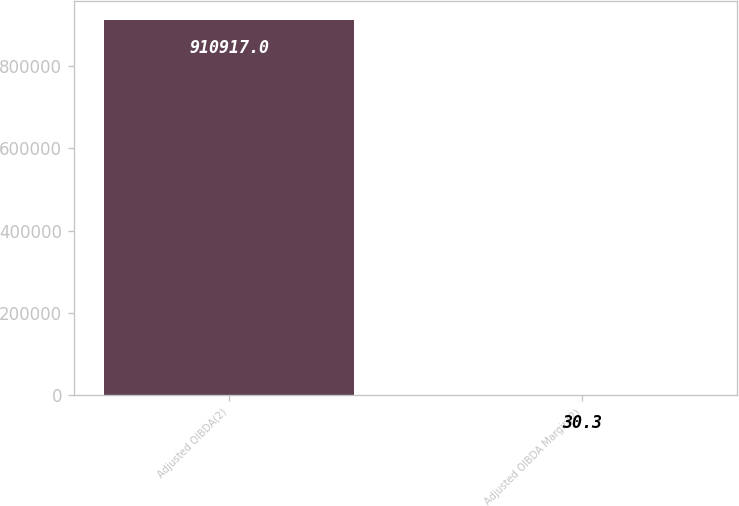<chart> <loc_0><loc_0><loc_500><loc_500><bar_chart><fcel>Adjusted OIBDA(2)<fcel>Adjusted OIBDA Margin(2)<nl><fcel>910917<fcel>30.3<nl></chart> 